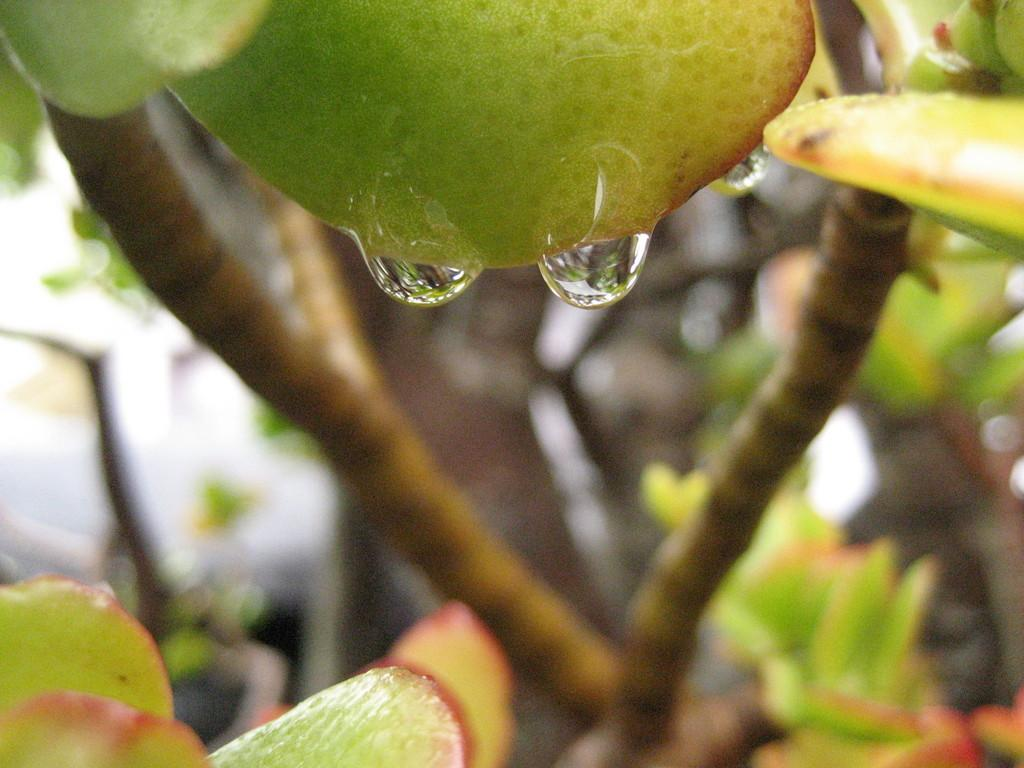What type of plant can be seen in the image? There is a tree in the image. What colors are the leaves on the tree? The leaves on the tree are green and orange in color. What else can be seen in the image besides the tree? There are water drops visible in the image. How would you describe the background of the image? The background of the image appears blurry. How many eggs are being used to change the color of the tree in the image? There are no eggs or any indication of color-changing in the image; the tree's leaves are naturally green and orange. Can you hear the tree talking to the water drops in the image? Trees and water drops do not have the ability to talk, so this cannot be observed in the image. 